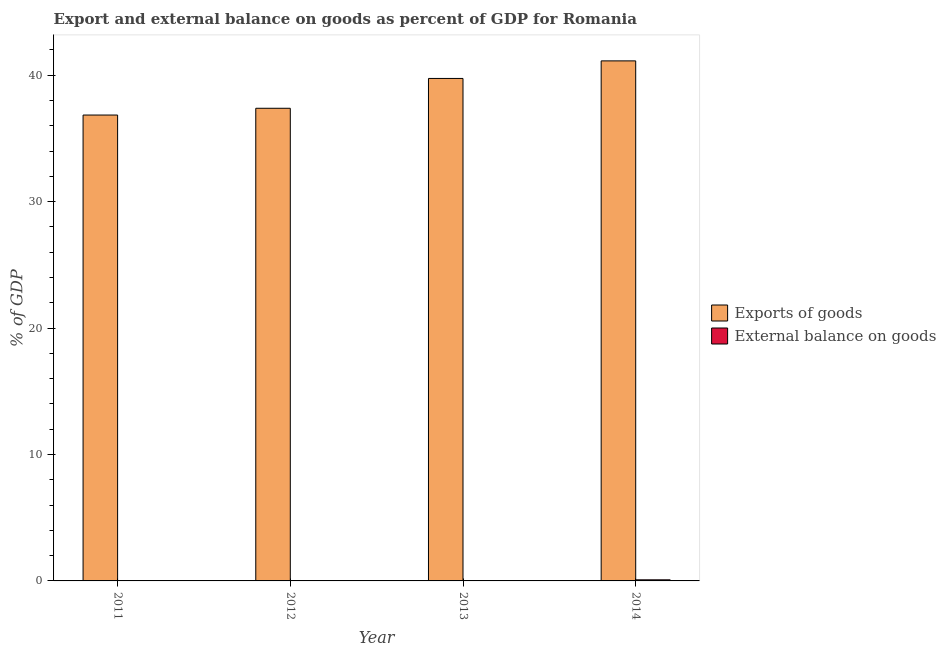Are the number of bars per tick equal to the number of legend labels?
Offer a terse response. No. Are the number of bars on each tick of the X-axis equal?
Your response must be concise. No. How many bars are there on the 2nd tick from the left?
Offer a terse response. 1. What is the label of the 3rd group of bars from the left?
Ensure brevity in your answer.  2013. What is the external balance on goods as percentage of gdp in 2014?
Your response must be concise. 0.09. Across all years, what is the maximum export of goods as percentage of gdp?
Keep it short and to the point. 41.13. Across all years, what is the minimum export of goods as percentage of gdp?
Your answer should be very brief. 36.85. In which year was the external balance on goods as percentage of gdp maximum?
Your response must be concise. 2014. What is the total external balance on goods as percentage of gdp in the graph?
Keep it short and to the point. 0.09. What is the difference between the export of goods as percentage of gdp in 2011 and that in 2013?
Provide a succinct answer. -2.89. What is the difference between the export of goods as percentage of gdp in 2011 and the external balance on goods as percentage of gdp in 2014?
Provide a short and direct response. -4.28. What is the average external balance on goods as percentage of gdp per year?
Ensure brevity in your answer.  0.02. In the year 2011, what is the difference between the export of goods as percentage of gdp and external balance on goods as percentage of gdp?
Provide a short and direct response. 0. In how many years, is the external balance on goods as percentage of gdp greater than 26 %?
Give a very brief answer. 0. What is the ratio of the export of goods as percentage of gdp in 2011 to that in 2013?
Make the answer very short. 0.93. Is the export of goods as percentage of gdp in 2012 less than that in 2013?
Your answer should be very brief. Yes. What is the difference between the highest and the second highest export of goods as percentage of gdp?
Your answer should be very brief. 1.39. What is the difference between the highest and the lowest external balance on goods as percentage of gdp?
Provide a succinct answer. 0.09. In how many years, is the external balance on goods as percentage of gdp greater than the average external balance on goods as percentage of gdp taken over all years?
Provide a succinct answer. 1. Are all the bars in the graph horizontal?
Your answer should be compact. No. What is the difference between two consecutive major ticks on the Y-axis?
Ensure brevity in your answer.  10. Does the graph contain any zero values?
Provide a succinct answer. Yes. Where does the legend appear in the graph?
Your response must be concise. Center right. How many legend labels are there?
Make the answer very short. 2. How are the legend labels stacked?
Your response must be concise. Vertical. What is the title of the graph?
Make the answer very short. Export and external balance on goods as percent of GDP for Romania. Does "Secondary" appear as one of the legend labels in the graph?
Keep it short and to the point. No. What is the label or title of the X-axis?
Ensure brevity in your answer.  Year. What is the label or title of the Y-axis?
Offer a very short reply. % of GDP. What is the % of GDP in Exports of goods in 2011?
Your answer should be compact. 36.85. What is the % of GDP of External balance on goods in 2011?
Your answer should be very brief. 0. What is the % of GDP in Exports of goods in 2012?
Offer a very short reply. 37.38. What is the % of GDP of External balance on goods in 2012?
Make the answer very short. 0. What is the % of GDP of Exports of goods in 2013?
Keep it short and to the point. 39.74. What is the % of GDP of Exports of goods in 2014?
Provide a succinct answer. 41.13. What is the % of GDP in External balance on goods in 2014?
Offer a terse response. 0.09. Across all years, what is the maximum % of GDP in Exports of goods?
Offer a very short reply. 41.13. Across all years, what is the maximum % of GDP in External balance on goods?
Keep it short and to the point. 0.09. Across all years, what is the minimum % of GDP in Exports of goods?
Make the answer very short. 36.85. Across all years, what is the minimum % of GDP in External balance on goods?
Give a very brief answer. 0. What is the total % of GDP in Exports of goods in the graph?
Offer a very short reply. 155.1. What is the total % of GDP in External balance on goods in the graph?
Keep it short and to the point. 0.09. What is the difference between the % of GDP of Exports of goods in 2011 and that in 2012?
Offer a terse response. -0.54. What is the difference between the % of GDP of Exports of goods in 2011 and that in 2013?
Make the answer very short. -2.89. What is the difference between the % of GDP of Exports of goods in 2011 and that in 2014?
Your answer should be very brief. -4.28. What is the difference between the % of GDP in Exports of goods in 2012 and that in 2013?
Your answer should be compact. -2.36. What is the difference between the % of GDP of Exports of goods in 2012 and that in 2014?
Your answer should be compact. -3.75. What is the difference between the % of GDP of Exports of goods in 2013 and that in 2014?
Give a very brief answer. -1.39. What is the difference between the % of GDP in Exports of goods in 2011 and the % of GDP in External balance on goods in 2014?
Offer a very short reply. 36.76. What is the difference between the % of GDP in Exports of goods in 2012 and the % of GDP in External balance on goods in 2014?
Make the answer very short. 37.29. What is the difference between the % of GDP of Exports of goods in 2013 and the % of GDP of External balance on goods in 2014?
Provide a short and direct response. 39.65. What is the average % of GDP of Exports of goods per year?
Your answer should be compact. 38.77. What is the average % of GDP in External balance on goods per year?
Keep it short and to the point. 0.02. In the year 2014, what is the difference between the % of GDP in Exports of goods and % of GDP in External balance on goods?
Offer a terse response. 41.04. What is the ratio of the % of GDP in Exports of goods in 2011 to that in 2012?
Your answer should be compact. 0.99. What is the ratio of the % of GDP in Exports of goods in 2011 to that in 2013?
Keep it short and to the point. 0.93. What is the ratio of the % of GDP of Exports of goods in 2011 to that in 2014?
Your answer should be very brief. 0.9. What is the ratio of the % of GDP of Exports of goods in 2012 to that in 2013?
Offer a very short reply. 0.94. What is the ratio of the % of GDP in Exports of goods in 2012 to that in 2014?
Your answer should be compact. 0.91. What is the ratio of the % of GDP of Exports of goods in 2013 to that in 2014?
Keep it short and to the point. 0.97. What is the difference between the highest and the second highest % of GDP in Exports of goods?
Offer a terse response. 1.39. What is the difference between the highest and the lowest % of GDP of Exports of goods?
Keep it short and to the point. 4.28. What is the difference between the highest and the lowest % of GDP in External balance on goods?
Provide a short and direct response. 0.09. 